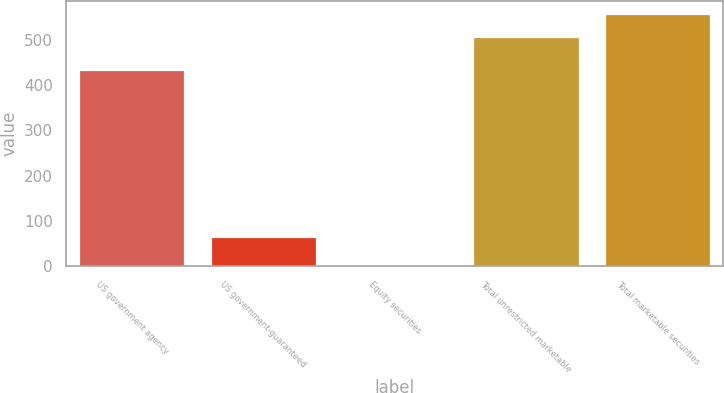Convert chart. <chart><loc_0><loc_0><loc_500><loc_500><bar_chart><fcel>US government agency<fcel>US government-guaranteed<fcel>Equity securities<fcel>Total unrestricted marketable<fcel>Total marketable securities<nl><fcel>434.4<fcel>64<fcel>3.6<fcel>506.8<fcel>557.83<nl></chart> 